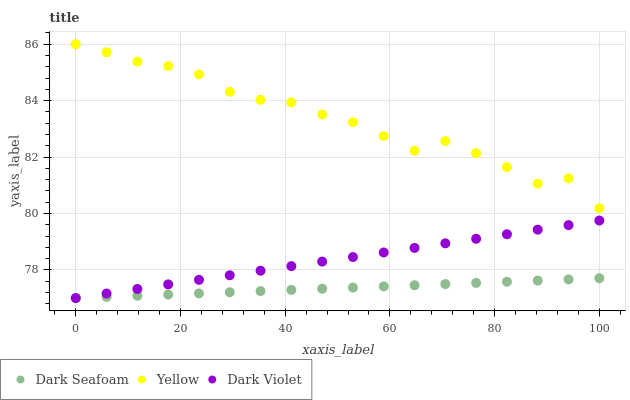Does Dark Seafoam have the minimum area under the curve?
Answer yes or no. Yes. Does Yellow have the maximum area under the curve?
Answer yes or no. Yes. Does Dark Violet have the minimum area under the curve?
Answer yes or no. No. Does Dark Violet have the maximum area under the curve?
Answer yes or no. No. Is Dark Violet the smoothest?
Answer yes or no. Yes. Is Yellow the roughest?
Answer yes or no. Yes. Is Yellow the smoothest?
Answer yes or no. No. Is Dark Violet the roughest?
Answer yes or no. No. Does Dark Seafoam have the lowest value?
Answer yes or no. Yes. Does Yellow have the lowest value?
Answer yes or no. No. Does Yellow have the highest value?
Answer yes or no. Yes. Does Dark Violet have the highest value?
Answer yes or no. No. Is Dark Seafoam less than Yellow?
Answer yes or no. Yes. Is Yellow greater than Dark Violet?
Answer yes or no. Yes. Does Dark Violet intersect Dark Seafoam?
Answer yes or no. Yes. Is Dark Violet less than Dark Seafoam?
Answer yes or no. No. Is Dark Violet greater than Dark Seafoam?
Answer yes or no. No. Does Dark Seafoam intersect Yellow?
Answer yes or no. No. 